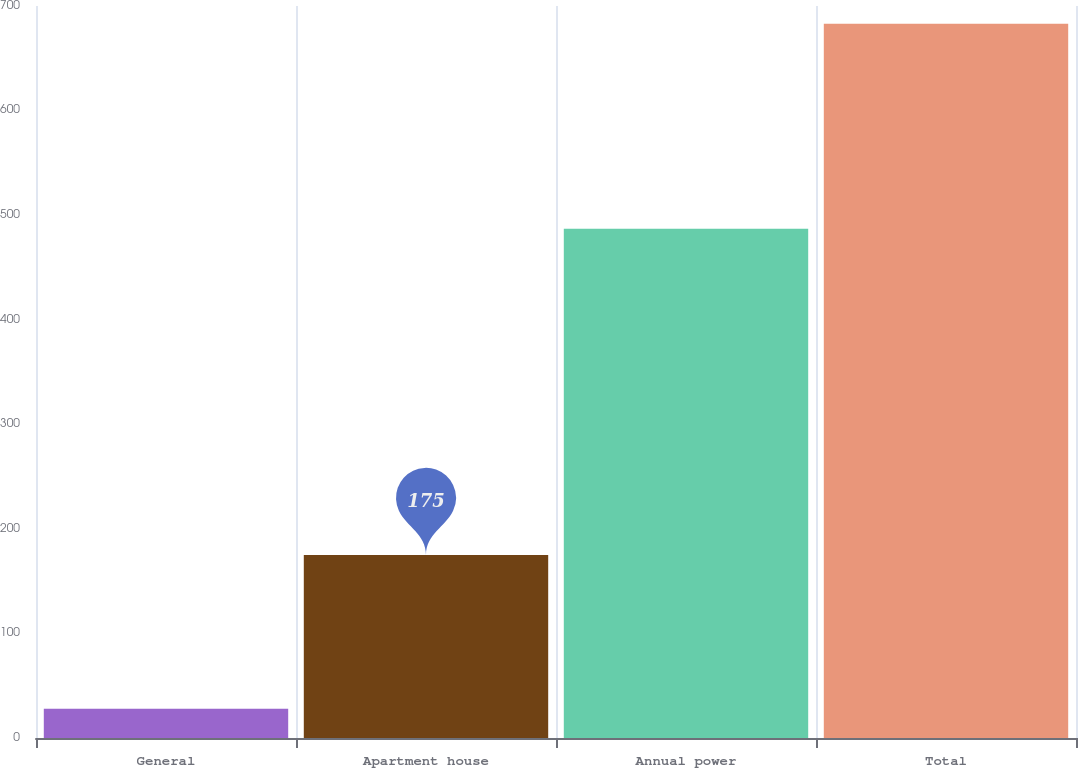Convert chart. <chart><loc_0><loc_0><loc_500><loc_500><bar_chart><fcel>General<fcel>Apartment house<fcel>Annual power<fcel>Total<nl><fcel>28<fcel>175<fcel>487<fcel>683<nl></chart> 